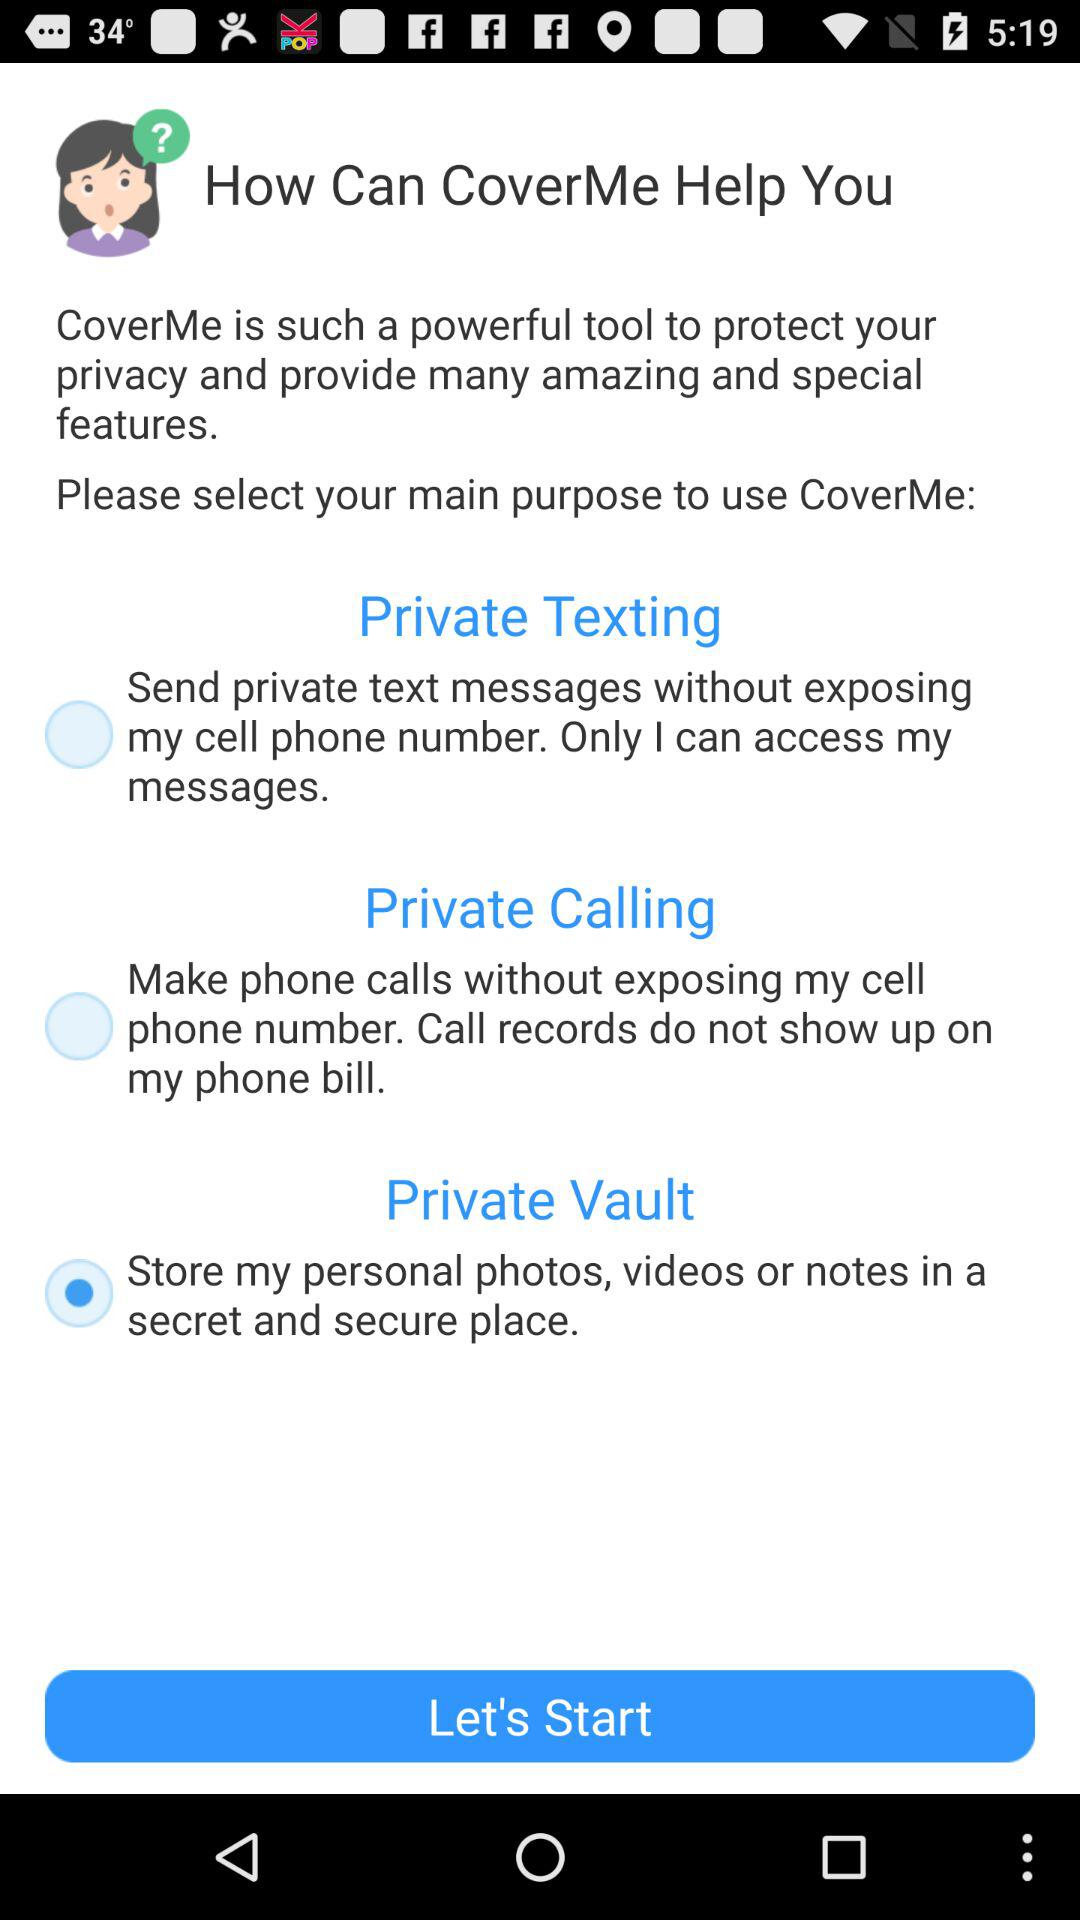What is private texting? Private texting is "Send private text messages without exposing my cell phone number. Only I can access my messages". 